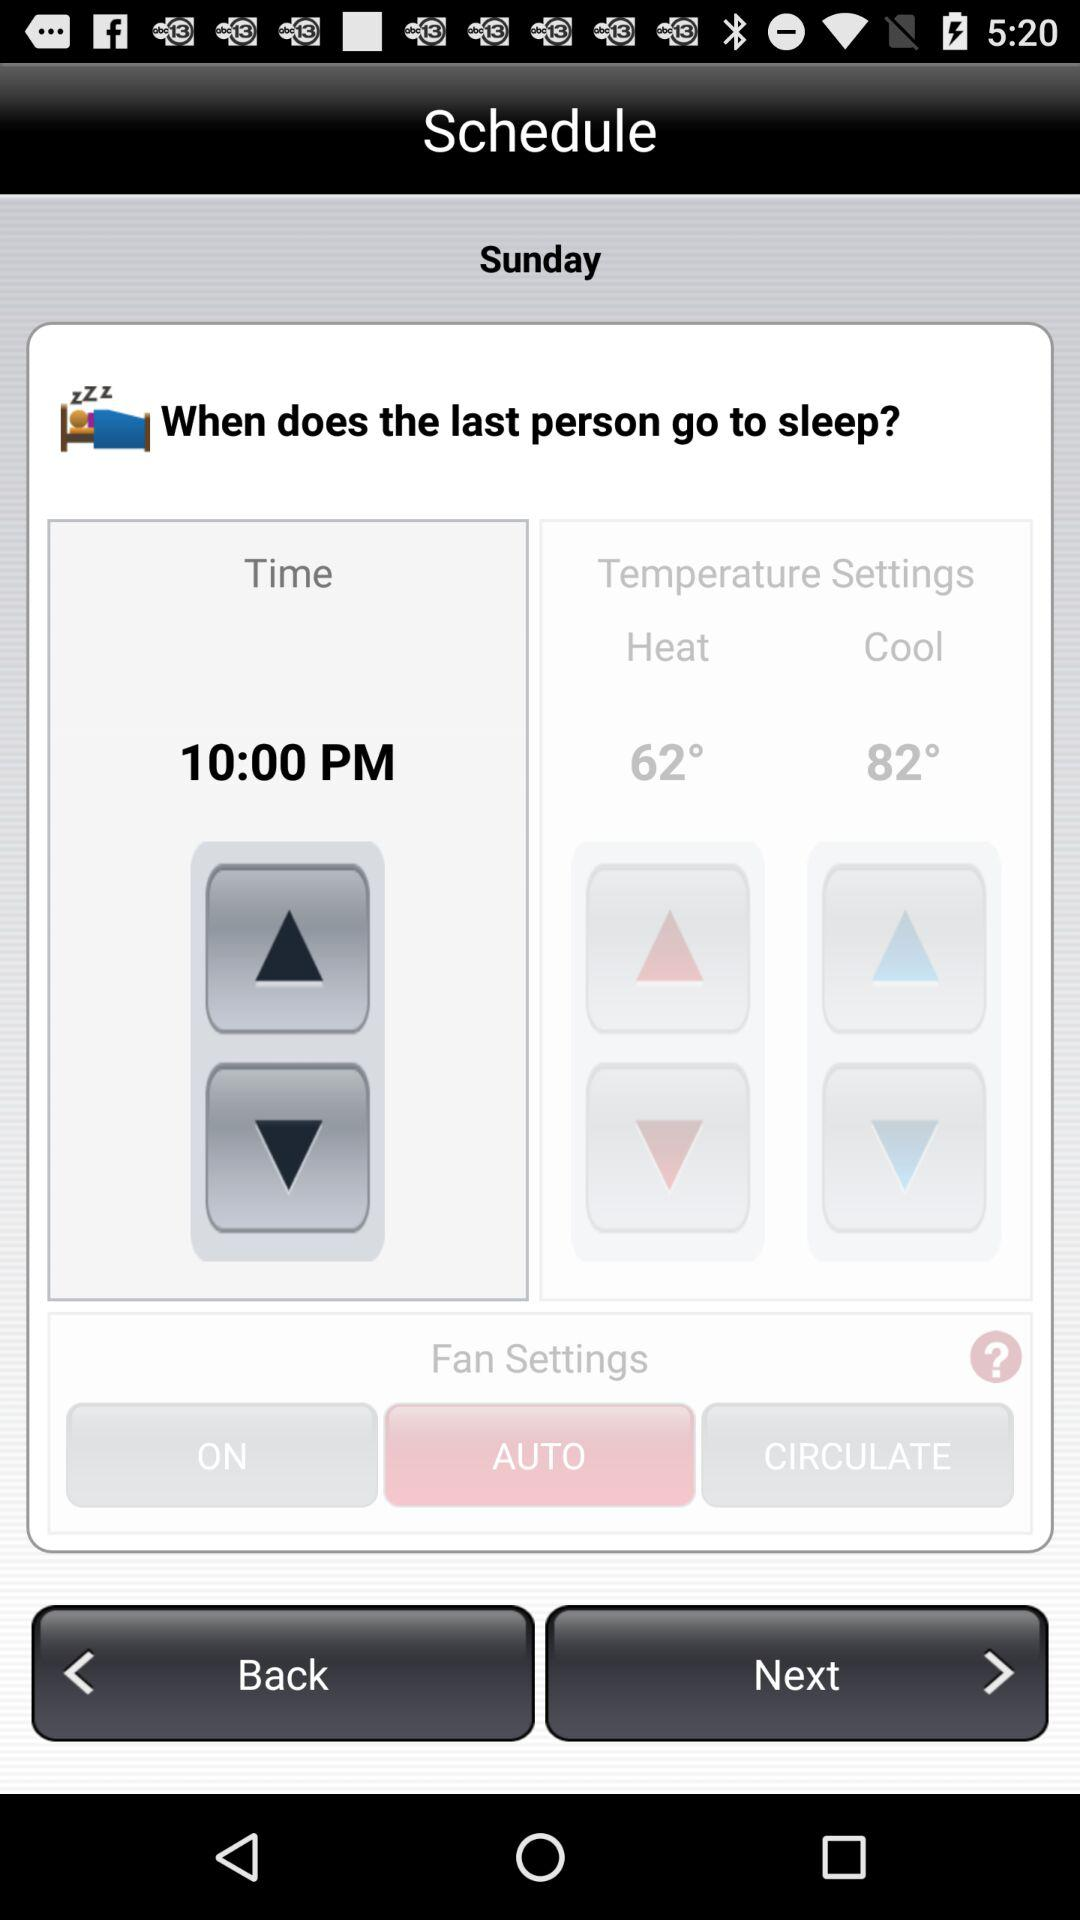What is the heat temperature? The heat temperature is 62°. 